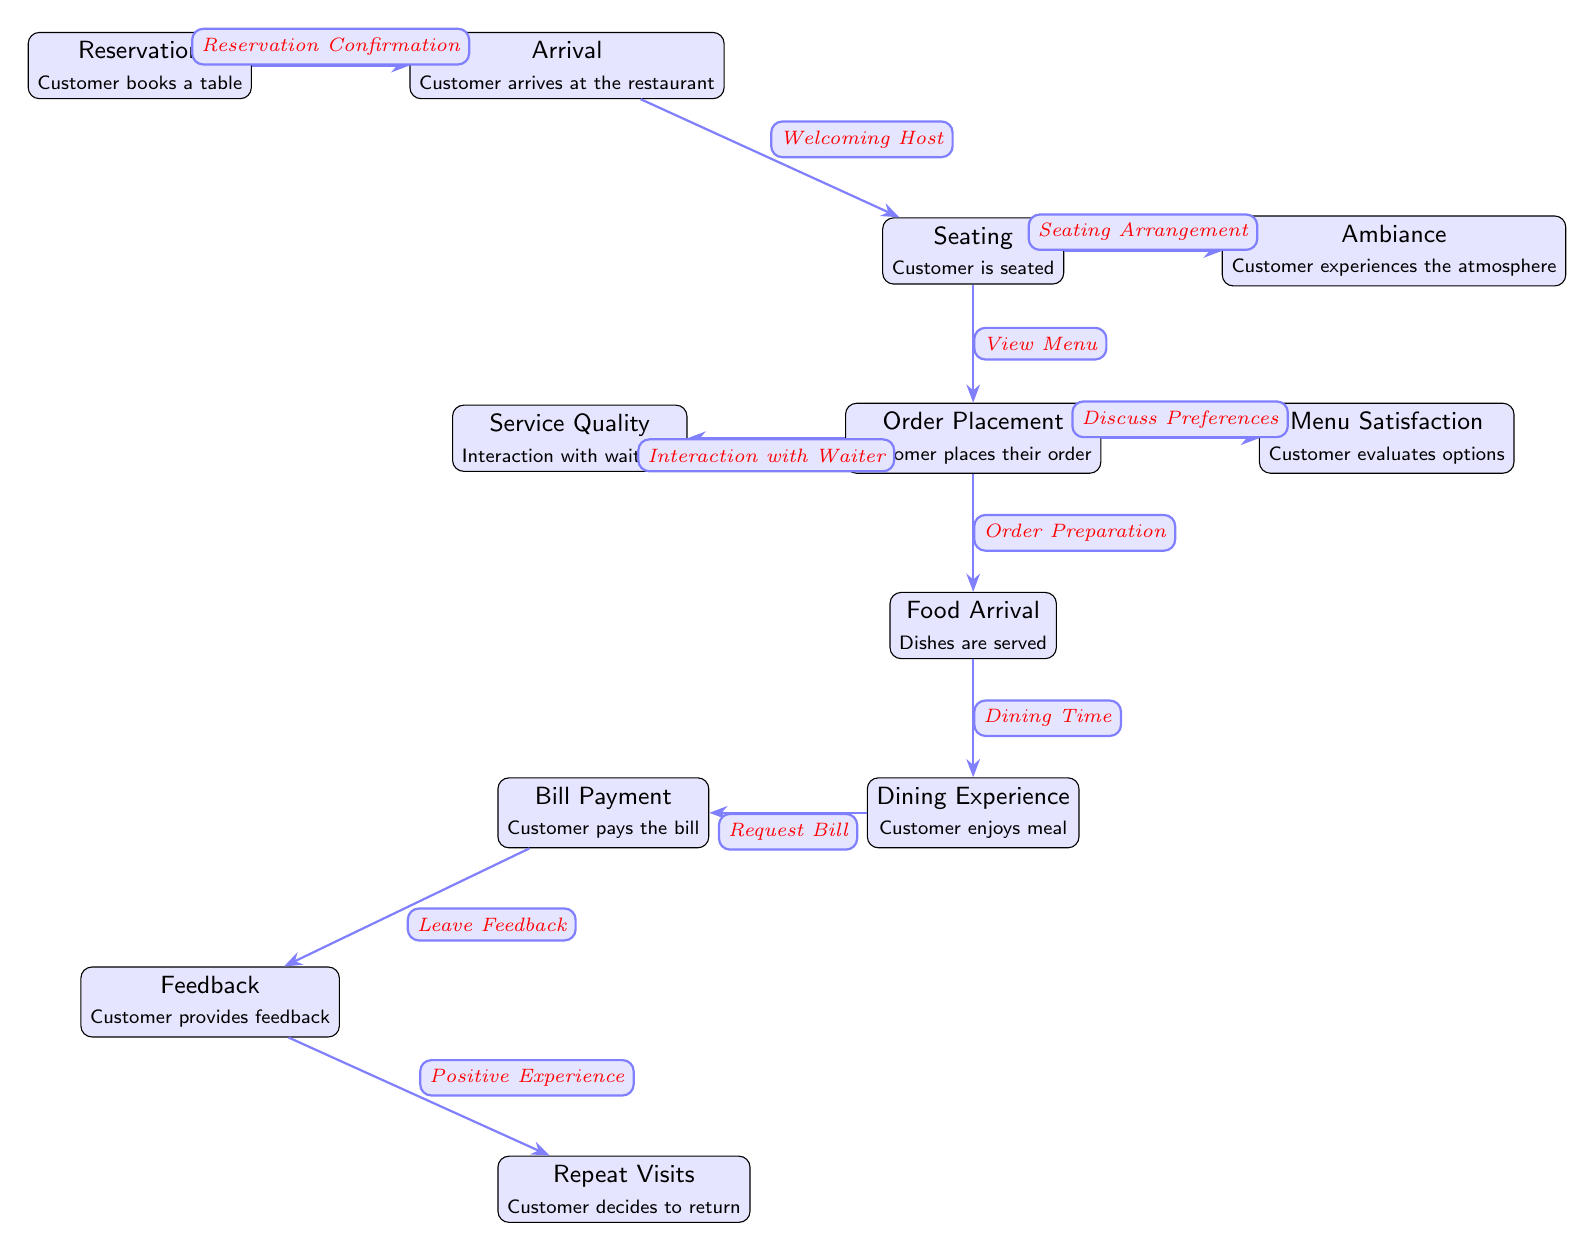What is the first node in the customer experience journey? The first node in the journey is "Reservation," where the customer books a table.
Answer: Reservation How many nodes are present in the diagram? The diagram has a total of 12 nodes representing different stages in the customer experience journey.
Answer: 12 What is the last step in the dining experience? The last step is "Repeat Visits," where the customer decides to return based on their experience.
Answer: Repeat Visits What touchpoint follows 'Food Arrival'? The touchpoint that follows 'Food Arrival' is 'Dining Experience,' where the customer enjoys their meal.
Answer: Dining Experience Which touchpoint involves interaction with the waitstaff? The touchpoint involving interaction with the waitstaff is "Service Quality," which relates to the customer’s experience with the staff.
Answer: Service Quality What is the connection between 'Bill Payment' and 'Feedback'? The connection is that 'Bill Payment' leads into 'Feedback,' indicating that customers provide feedback after settling their bill.
Answer: Feedback If a customer is unhappy with service quality, which step might they skip? If a customer is unhappy with service quality, they might skip 'Repeat Visits,' as it is based on a positive experience.
Answer: Repeat Visits What step comes immediately after 'Ambiance'? The step that comes immediately after 'Ambiance' is 'Order Placement,' where the customer places their order.
Answer: Order Placement What are the two options after 'Order Placement'? After 'Order Placement,' the two options are 'Service Quality' and 'Menu Satisfaction,' referring to the customer's interaction with the waitstaff and evaluating menu options.
Answer: Service Quality, Menu Satisfaction 